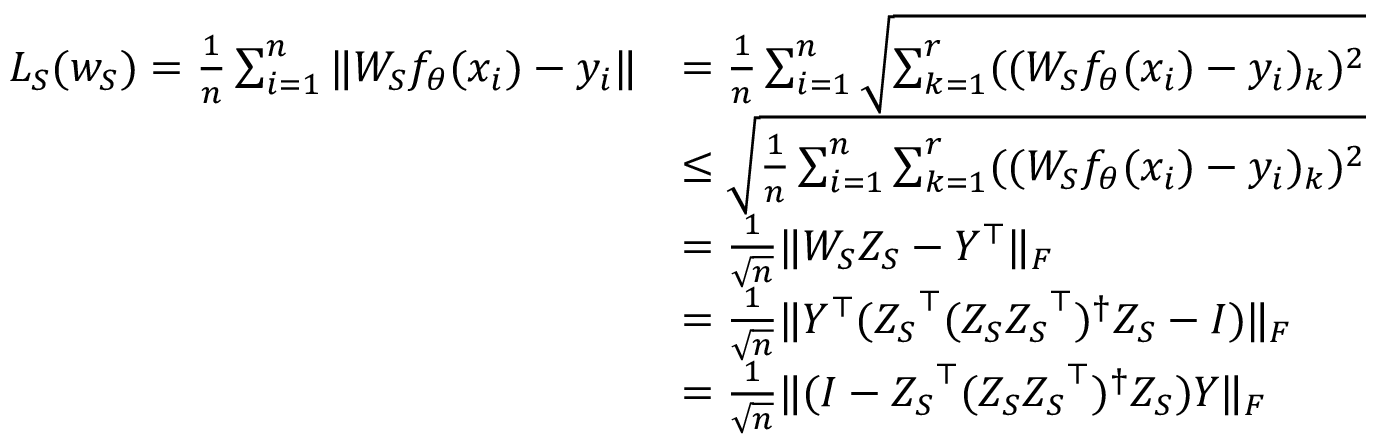<formula> <loc_0><loc_0><loc_500><loc_500>\begin{array} { r l } { L _ { S } ( w _ { S } ) = \frac { 1 } { n } \sum _ { i = 1 } ^ { n } \| W _ { S } f _ { \theta } ( x _ { i } ) - y _ { i } \| } & { = \frac { 1 } { n } \sum _ { i = 1 } ^ { n } \sqrt { \sum _ { k = 1 } ^ { r } ( ( W _ { S } f _ { \theta } ( x _ { i } ) - y _ { i } ) _ { k } ) ^ { 2 } } } \\ & { \leq \sqrt { \frac { 1 } { n } \sum _ { i = 1 } ^ { n } \sum _ { k = 1 } ^ { r } ( ( W _ { S } f _ { \theta } ( x _ { i } ) - y _ { i } ) _ { k } ) ^ { 2 } } } \\ & { = \frac { 1 } { \sqrt { n } } \| W _ { S } { Z _ { S } } - Y ^ { \top } \| _ { F } } \\ & { = \frac { 1 } { \sqrt { n } } \| Y ^ { \top } ( { Z _ { S } } ^ { \top } ( { Z _ { S } } { Z _ { S } } ^ { \top } ) ^ { \dagger } { Z _ { S } } - I ) \| _ { F } } \\ & { = \frac { 1 } { \sqrt { n } } \| ( I - { Z _ { S } } ^ { \top } ( { Z _ { S } } { Z _ { S } } ^ { \top } ) ^ { \dagger } { Z _ { S } } ) Y \| _ { F } } \end{array}</formula> 